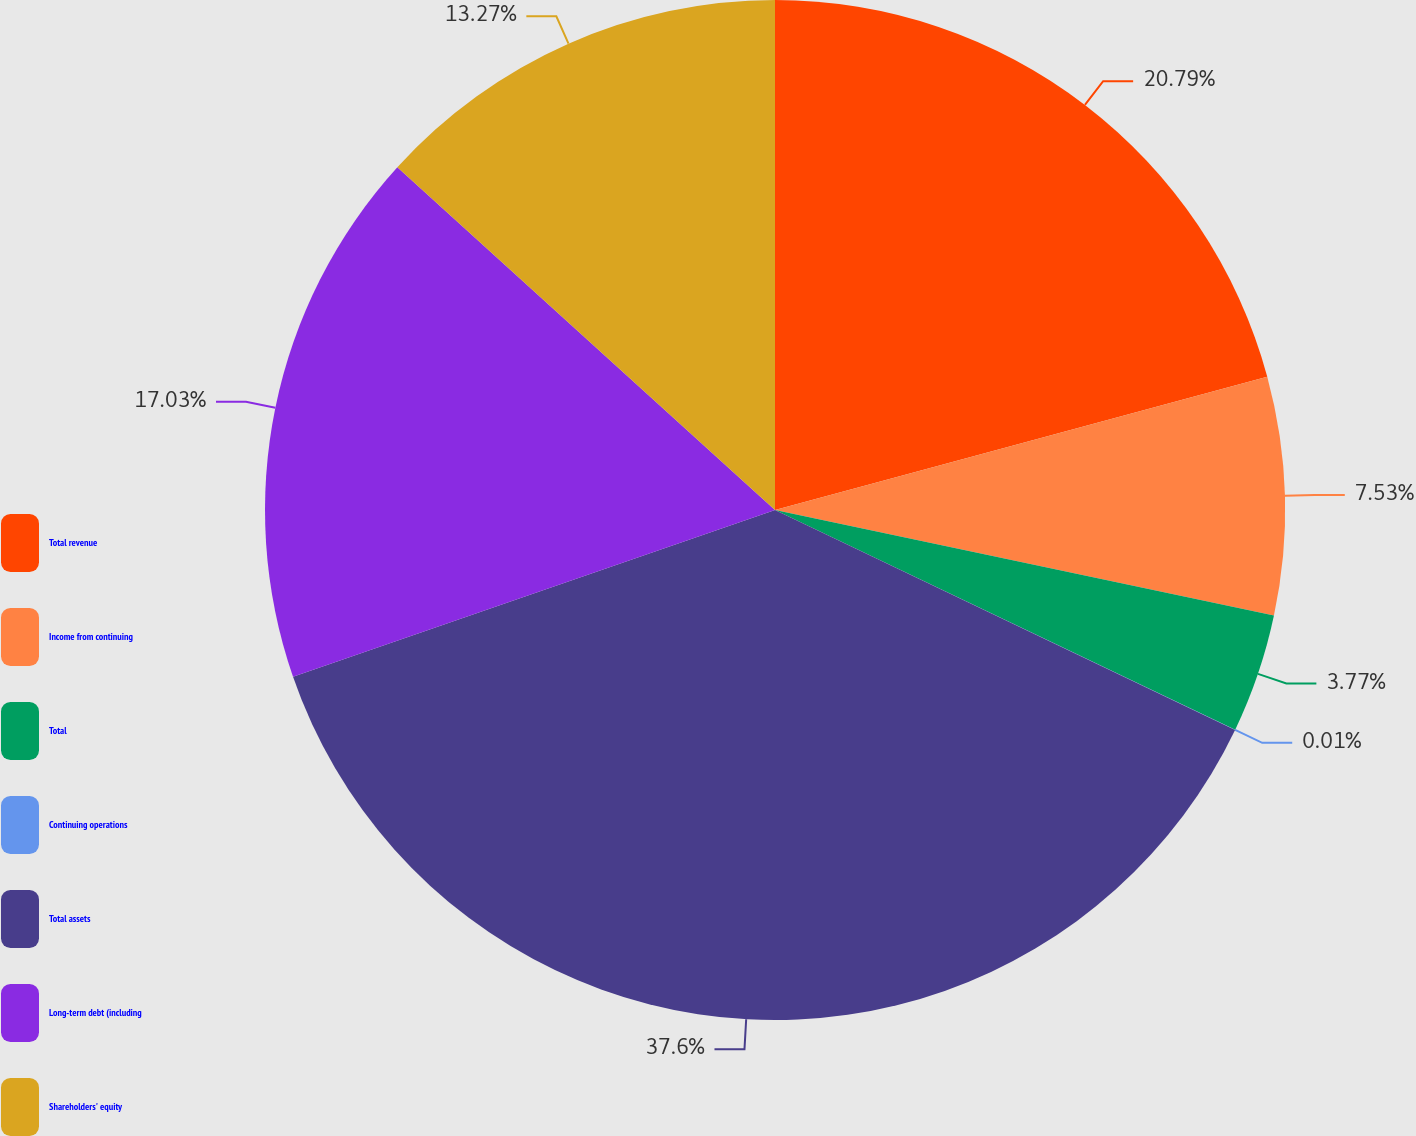Convert chart. <chart><loc_0><loc_0><loc_500><loc_500><pie_chart><fcel>Total revenue<fcel>Income from continuing<fcel>Total<fcel>Continuing operations<fcel>Total assets<fcel>Long-term debt (including<fcel>Shareholders' equity<nl><fcel>20.79%<fcel>7.53%<fcel>3.77%<fcel>0.01%<fcel>37.6%<fcel>17.03%<fcel>13.27%<nl></chart> 